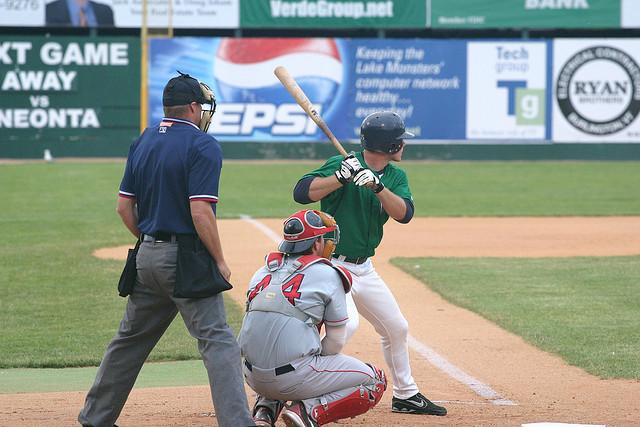What soda has an ad in the back?
Concise answer only. Pepsi. Does this appear to be a child's baseball game?
Quick response, please. No. What is the number on the back of the catcher?
Keep it brief. 44. 